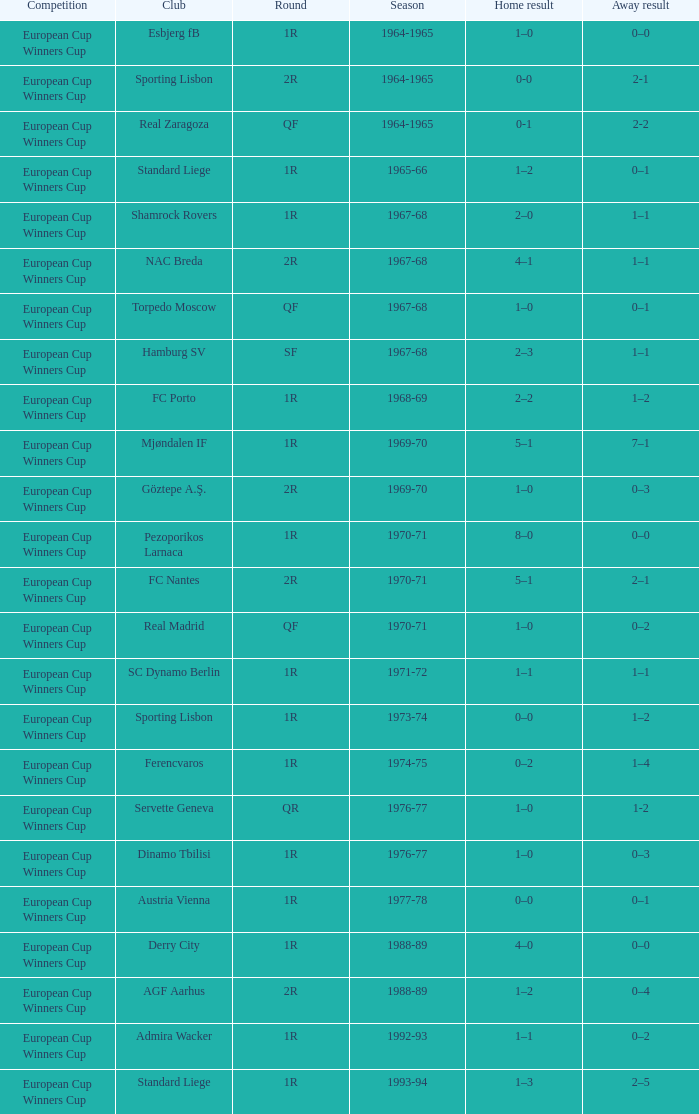Away result of 1-2 has what season? 1976-77. 